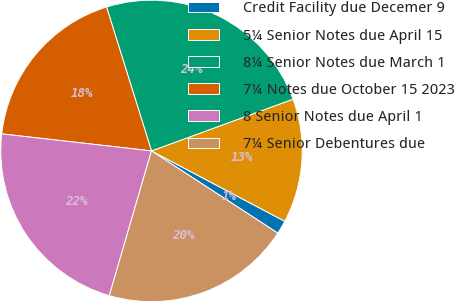<chart> <loc_0><loc_0><loc_500><loc_500><pie_chart><fcel>Credit Facility due Decemer 9<fcel>5¼ Senior Notes due April 15<fcel>8¼ Senior Notes due March 1<fcel>7¼ Notes due October 15 2023<fcel>8 Senior Notes due April 1<fcel>7¼ Senior Debentures due<nl><fcel>1.45%<fcel>13.31%<fcel>24.24%<fcel>18.38%<fcel>22.29%<fcel>20.33%<nl></chart> 